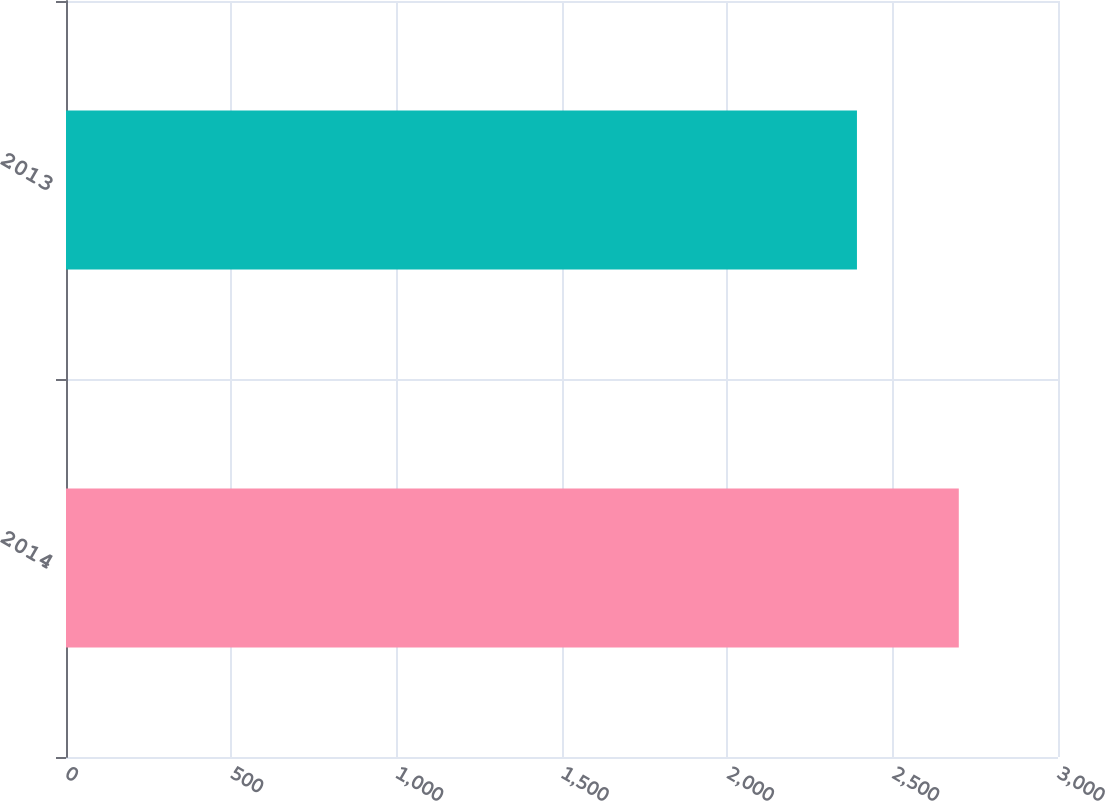<chart> <loc_0><loc_0><loc_500><loc_500><bar_chart><fcel>2014<fcel>2013<nl><fcel>2700<fcel>2392<nl></chart> 